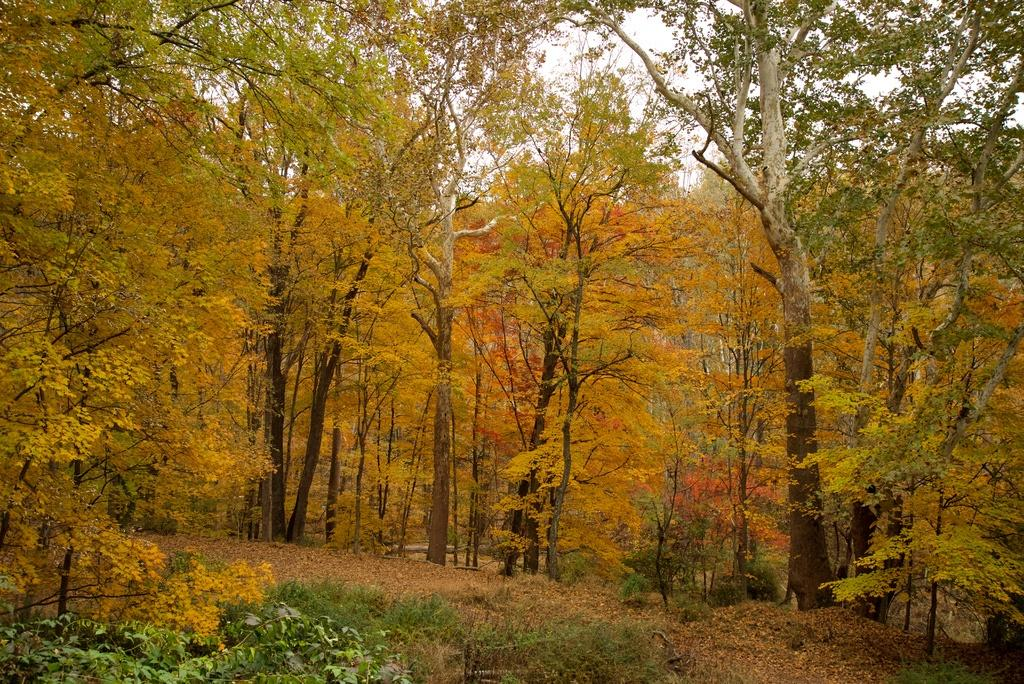What type of vegetation is in the center of the image? There are trees in the center of the image. What type of ground cover is at the bottom of the image? There is grass at the bottom of the image. What part of the natural environment is visible in the background of the image? The sky is visible in the background of the image. Can you tell me where the nearest store is located in the image? There is no store present in the image; it features trees, grass, and the sky. Is there anyone swimming in the image? There is no water or swimming activity depicted in the image. 